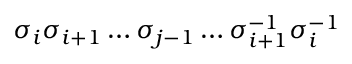<formula> <loc_0><loc_0><loc_500><loc_500>\sigma _ { i } \sigma _ { i + 1 } \dots \sigma _ { j - 1 } \dots \sigma _ { i + 1 } ^ { - 1 } \sigma _ { i } ^ { - 1 }</formula> 